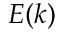<formula> <loc_0><loc_0><loc_500><loc_500>E ( k )</formula> 